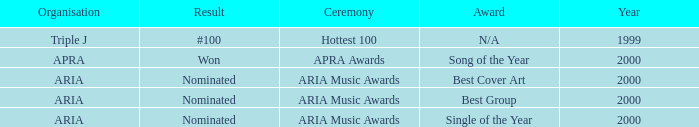What's the award for #100? N/A. 